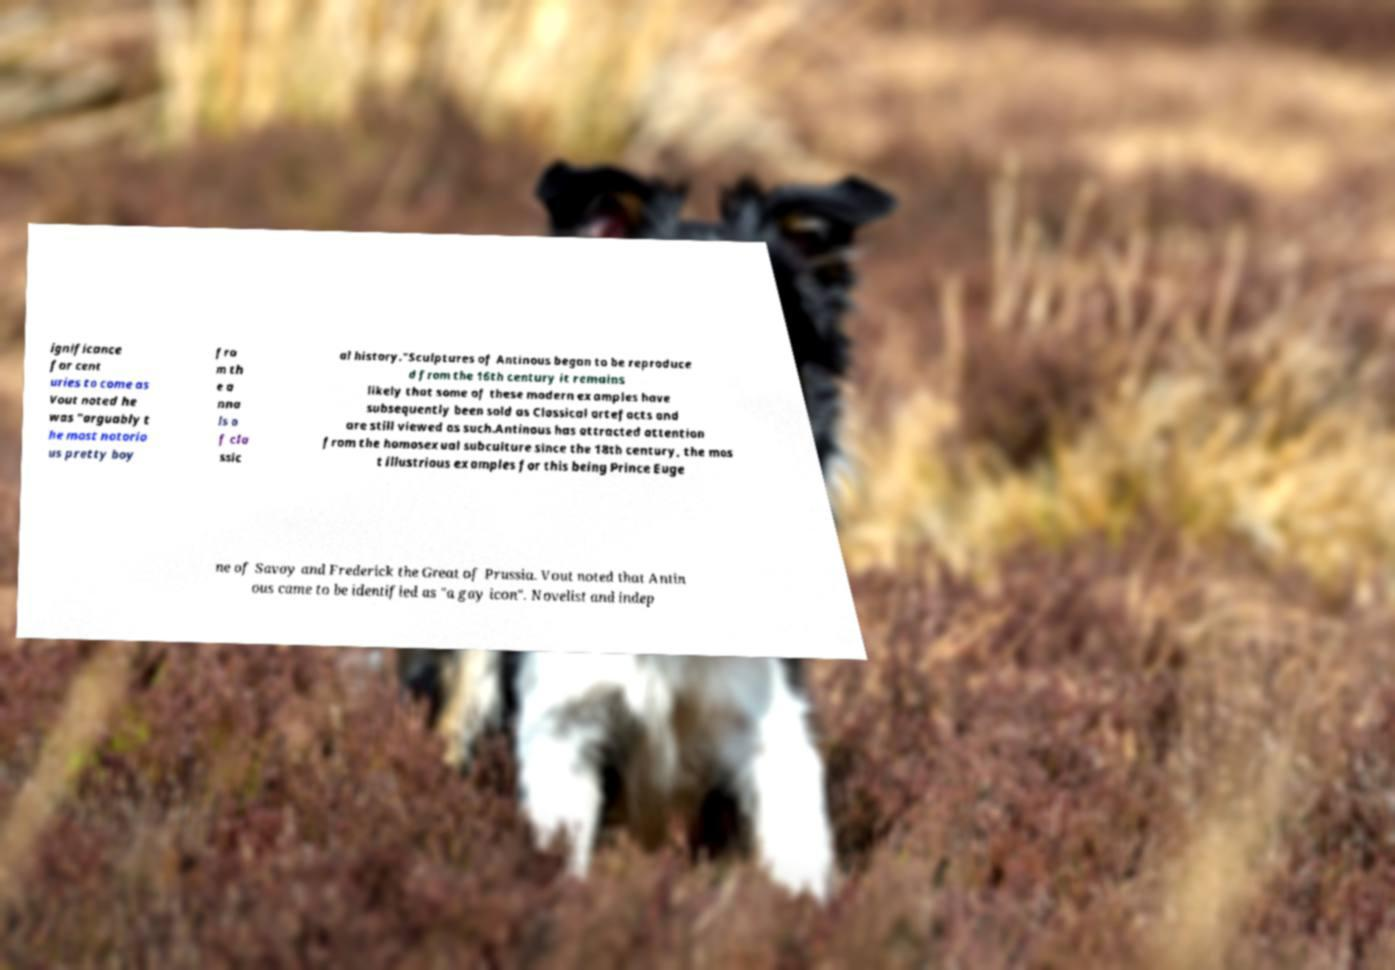There's text embedded in this image that I need extracted. Can you transcribe it verbatim? ignificance for cent uries to come as Vout noted he was "arguably t he most notorio us pretty boy fro m th e a nna ls o f cla ssic al history."Sculptures of Antinous began to be reproduce d from the 16th century it remains likely that some of these modern examples have subsequently been sold as Classical artefacts and are still viewed as such.Antinous has attracted attention from the homosexual subculture since the 18th century, the mos t illustrious examples for this being Prince Euge ne of Savoy and Frederick the Great of Prussia. Vout noted that Antin ous came to be identified as "a gay icon". Novelist and indep 